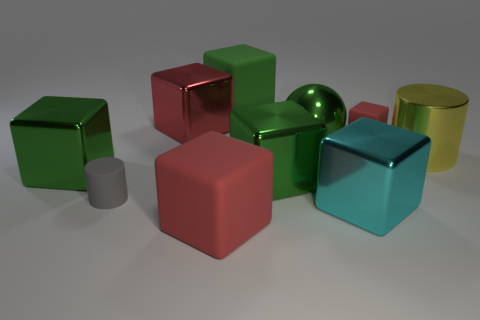What number of purple things are either large spheres or tiny cylinders?
Ensure brevity in your answer.  0. What color is the rubber cylinder?
Your answer should be compact. Gray. Are there fewer large matte cubes that are behind the tiny cylinder than big blocks that are in front of the large cylinder?
Keep it short and to the point. Yes. What is the shape of the rubber thing that is both behind the gray rubber thing and on the left side of the small red rubber object?
Keep it short and to the point. Cube. What number of small gray matte things have the same shape as the large cyan object?
Ensure brevity in your answer.  0. There is a yellow thing that is made of the same material as the cyan cube; what size is it?
Give a very brief answer. Large. How many other red blocks are the same size as the red metal block?
Provide a succinct answer. 1. The matte object that is the same color as the big metallic ball is what size?
Your answer should be very brief. Large. What is the color of the cylinder to the left of the big rubber thing behind the green metal ball?
Give a very brief answer. Gray. Are there any large metal objects of the same color as the small block?
Your response must be concise. Yes. 